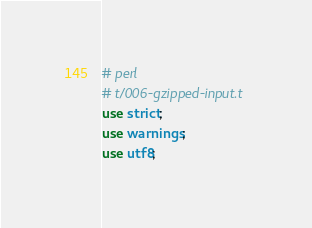<code> <loc_0><loc_0><loc_500><loc_500><_Perl_># perl
# t/006-gzipped-input.t
use strict;
use warnings;
use utf8;</code> 